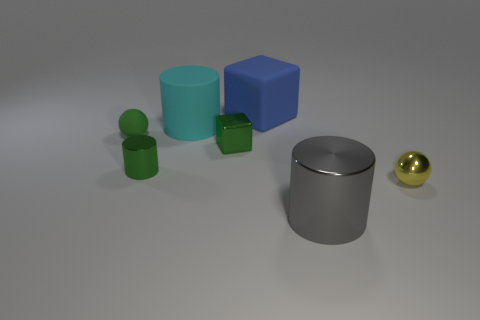Add 3 blue cubes. How many objects exist? 10 Subtract all blocks. How many objects are left? 5 Subtract all small yellow shiny spheres. Subtract all small yellow things. How many objects are left? 5 Add 7 large gray things. How many large gray things are left? 8 Add 5 matte things. How many matte things exist? 8 Subtract 0 purple cylinders. How many objects are left? 7 